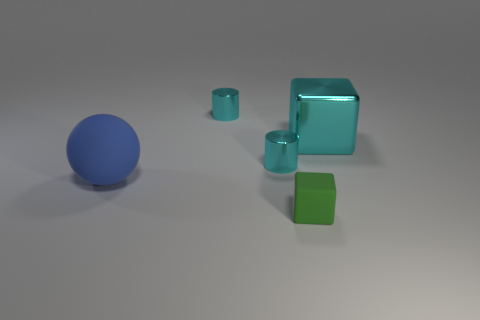Add 4 cyan shiny blocks. How many objects exist? 9 Subtract all cylinders. How many objects are left? 3 Subtract 2 cyan cylinders. How many objects are left? 3 Subtract all small cyan metallic things. Subtract all blue balls. How many objects are left? 2 Add 5 tiny blocks. How many tiny blocks are left? 6 Add 5 tiny blue cubes. How many tiny blue cubes exist? 5 